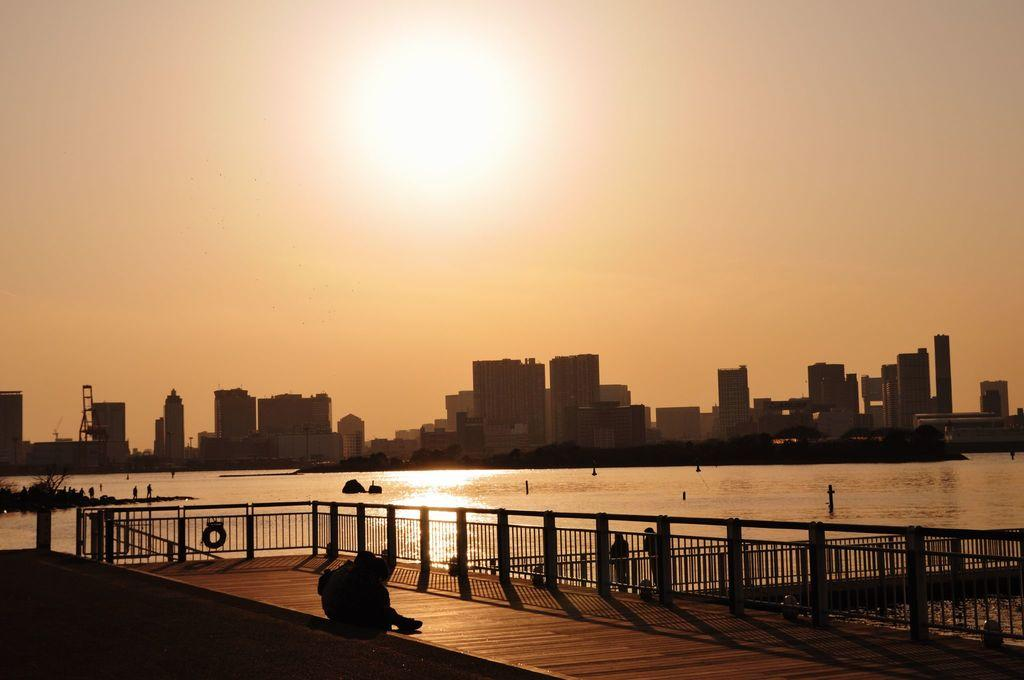What type of structure can be seen in the image? There are iron grilles in the image. Are there any people present in the image? Yes, some people are standing in the image, and a person is sitting in the image. What can be seen behind the iron grilles? There is water, buildings, and the sky visible behind the iron grilles. What type of insurance policy do the dogs in the image have? There are no dogs present in the image, so it is not possible to determine what type of insurance policy they might have. 